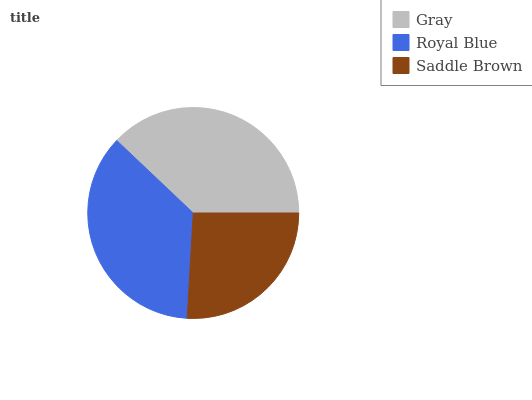Is Saddle Brown the minimum?
Answer yes or no. Yes. Is Gray the maximum?
Answer yes or no. Yes. Is Royal Blue the minimum?
Answer yes or no. No. Is Royal Blue the maximum?
Answer yes or no. No. Is Gray greater than Royal Blue?
Answer yes or no. Yes. Is Royal Blue less than Gray?
Answer yes or no. Yes. Is Royal Blue greater than Gray?
Answer yes or no. No. Is Gray less than Royal Blue?
Answer yes or no. No. Is Royal Blue the high median?
Answer yes or no. Yes. Is Royal Blue the low median?
Answer yes or no. Yes. Is Gray the high median?
Answer yes or no. No. Is Saddle Brown the low median?
Answer yes or no. No. 